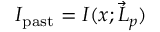<formula> <loc_0><loc_0><loc_500><loc_500>I _ { p a s t } = I ( x ; \vec { L } _ { p } )</formula> 